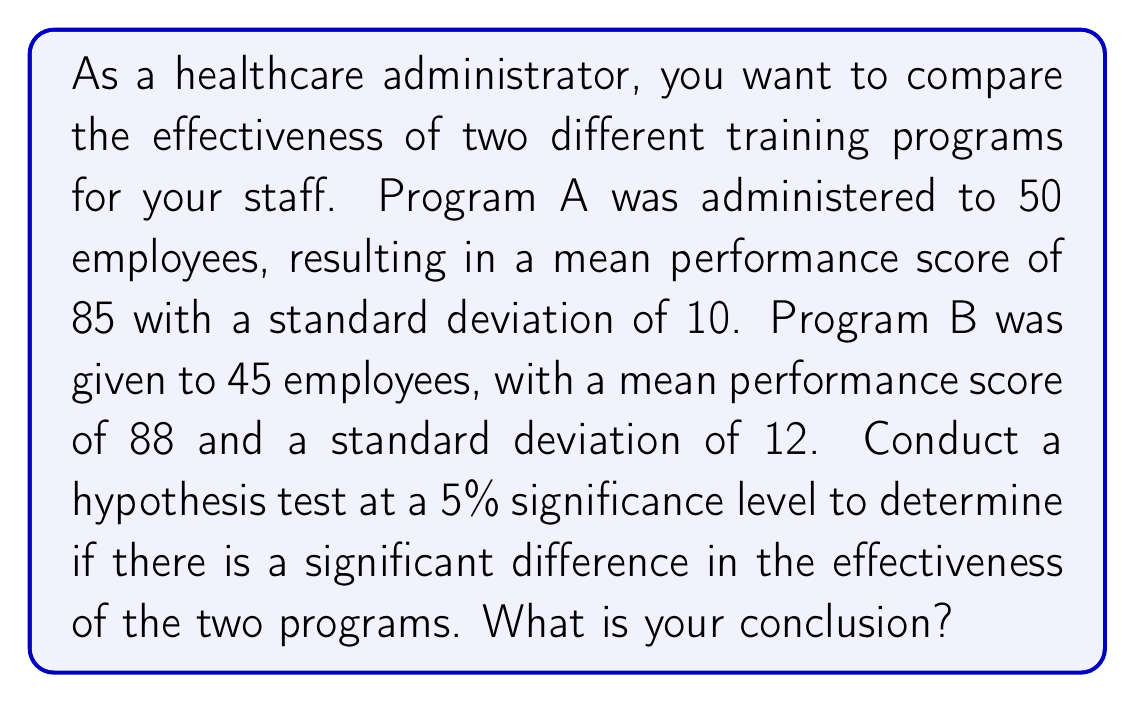Can you answer this question? Let's approach this step-by-step:

1) First, we need to set up our hypotheses:
   $H_0: \mu_A = \mu_B$ (null hypothesis: no difference between programs)
   $H_a: \mu_A \neq \mu_B$ (alternative hypothesis: there is a difference)

2) We'll use a two-sample t-test since we're comparing means from two independent groups.

3) Calculate the pooled standard error:
   $$SE = \sqrt{\frac{s_1^2}{n_1} + \frac{s_2^2}{n_2}} = \sqrt{\frac{10^2}{50} + \frac{12^2}{45}} = 2.2361$$

4) Calculate the t-statistic:
   $$t = \frac{(\bar{x}_1 - \bar{x}_2)}{SE} = \frac{(85 - 88)}{2.2361} = -1.3416$$

5) Degrees of freedom: $df = n_1 + n_2 - 2 = 50 + 45 - 2 = 93$

6) For a two-tailed test at 5% significance level, the critical t-value with 93 df is approximately ±1.9858.

7) Since |-1.3416| < 1.9858, we fail to reject the null hypothesis.

8) We can also calculate the p-value:
   p-value = 2 * P(T > |-1.3416|) ≈ 0.1830

9) Since 0.1830 > 0.05, we again fail to reject the null hypothesis.
Answer: Fail to reject the null hypothesis. There is not enough evidence to conclude that there is a significant difference in the effectiveness of the two training programs at the 5% significance level. 